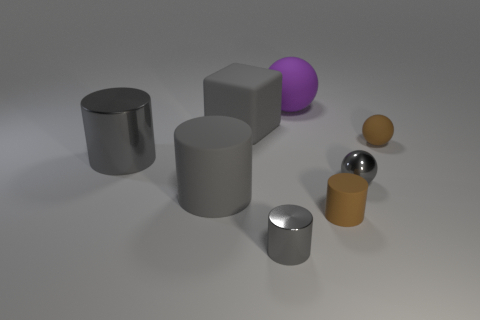What shape is the large shiny object?
Give a very brief answer. Cylinder. What material is the sphere that is in front of the tiny brown matte object right of the brown thing that is in front of the brown sphere?
Keep it short and to the point. Metal. Are there more rubber balls that are in front of the matte cube than big blue blocks?
Make the answer very short. Yes. There is a block that is the same size as the purple matte ball; what is its material?
Provide a short and direct response. Rubber. Are there any gray matte objects of the same size as the gray shiny sphere?
Provide a short and direct response. No. What size is the matte cylinder that is left of the purple sphere?
Your answer should be compact. Large. What is the size of the gray rubber cylinder?
Your response must be concise. Large. How many cylinders are large things or brown things?
Offer a terse response. 3. There is a purple object that is the same material as the large cube; what size is it?
Your answer should be very brief. Large. How many tiny metallic balls have the same color as the small matte cylinder?
Your answer should be very brief. 0. 